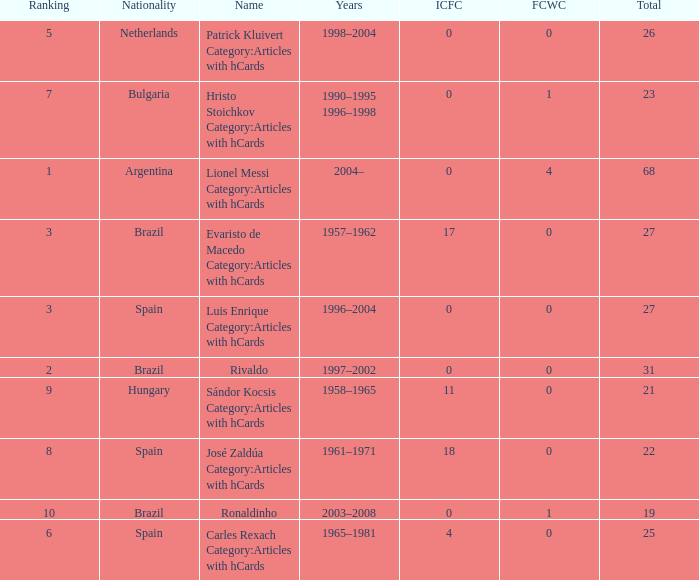What is the highest number of FCWC in the Years of 1958–1965, and an ICFC smaller than 11? None. Could you parse the entire table as a dict? {'header': ['Ranking', 'Nationality', 'Name', 'Years', 'ICFC', 'FCWC', 'Total'], 'rows': [['5', 'Netherlands', 'Patrick Kluivert Category:Articles with hCards', '1998–2004', '0', '0', '26'], ['7', 'Bulgaria', 'Hristo Stoichkov Category:Articles with hCards', '1990–1995 1996–1998', '0', '1', '23'], ['1', 'Argentina', 'Lionel Messi Category:Articles with hCards', '2004–', '0', '4', '68'], ['3', 'Brazil', 'Evaristo de Macedo Category:Articles with hCards', '1957–1962', '17', '0', '27'], ['3', 'Spain', 'Luis Enrique Category:Articles with hCards', '1996–2004', '0', '0', '27'], ['2', 'Brazil', 'Rivaldo', '1997–2002', '0', '0', '31'], ['9', 'Hungary', 'Sándor Kocsis Category:Articles with hCards', '1958–1965', '11', '0', '21'], ['8', 'Spain', 'José Zaldúa Category:Articles with hCards', '1961–1971', '18', '0', '22'], ['10', 'Brazil', 'Ronaldinho', '2003–2008', '0', '1', '19'], ['6', 'Spain', 'Carles Rexach Category:Articles with hCards', '1965–1981', '4', '0', '25']]} 